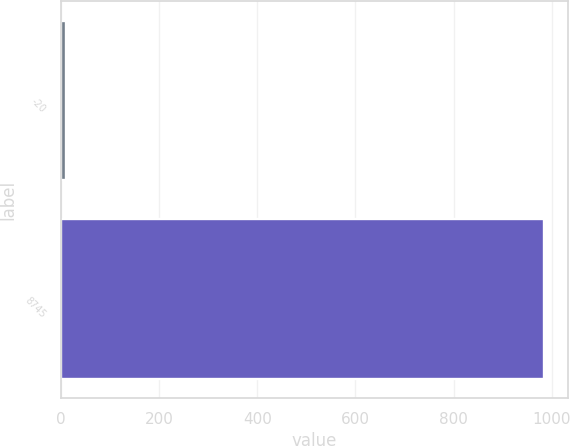Convert chart to OTSL. <chart><loc_0><loc_0><loc_500><loc_500><bar_chart><fcel>-20<fcel>8745<nl><fcel>10<fcel>983.8<nl></chart> 